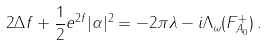Convert formula to latex. <formula><loc_0><loc_0><loc_500><loc_500>2 \Delta f + \frac { 1 } { 2 } e ^ { 2 f } | \alpha | ^ { 2 } = - 2 \pi \lambda - i \Lambda _ { \omega } ( F _ { A _ { 0 } } ^ { + } ) \, .</formula> 